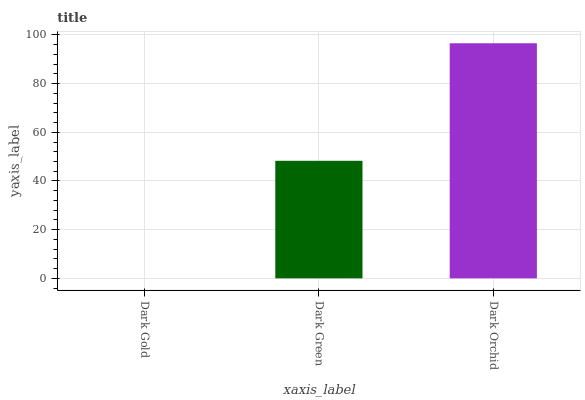Is Dark Green the minimum?
Answer yes or no. No. Is Dark Green the maximum?
Answer yes or no. No. Is Dark Green greater than Dark Gold?
Answer yes or no. Yes. Is Dark Gold less than Dark Green?
Answer yes or no. Yes. Is Dark Gold greater than Dark Green?
Answer yes or no. No. Is Dark Green less than Dark Gold?
Answer yes or no. No. Is Dark Green the high median?
Answer yes or no. Yes. Is Dark Green the low median?
Answer yes or no. Yes. Is Dark Orchid the high median?
Answer yes or no. No. Is Dark Orchid the low median?
Answer yes or no. No. 